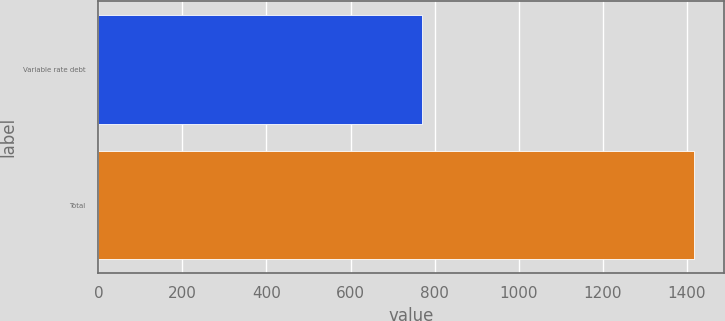Convert chart to OTSL. <chart><loc_0><loc_0><loc_500><loc_500><bar_chart><fcel>Variable rate debt<fcel>Total<nl><fcel>771<fcel>1418<nl></chart> 